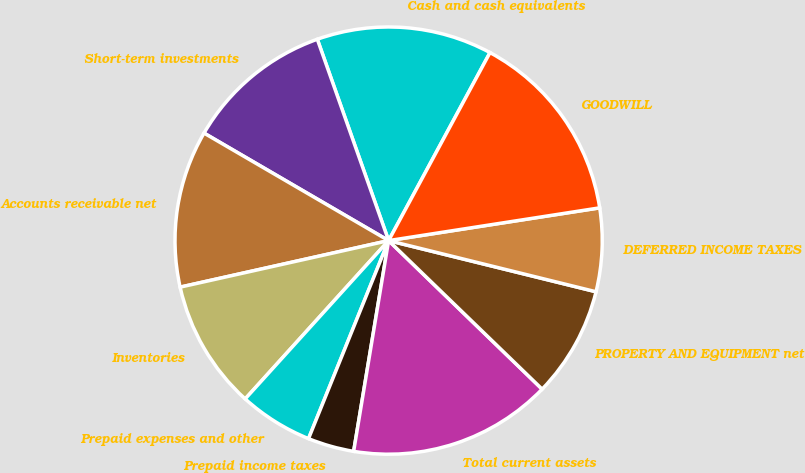Convert chart. <chart><loc_0><loc_0><loc_500><loc_500><pie_chart><fcel>Cash and cash equivalents<fcel>Short-term investments<fcel>Accounts receivable net<fcel>Inventories<fcel>Prepaid expenses and other<fcel>Prepaid income taxes<fcel>Total current assets<fcel>PROPERTY AND EQUIPMENT net<fcel>DEFERRED INCOME TAXES<fcel>GOODWILL<nl><fcel>13.29%<fcel>11.19%<fcel>11.89%<fcel>9.79%<fcel>5.6%<fcel>3.5%<fcel>15.38%<fcel>8.39%<fcel>6.3%<fcel>14.68%<nl></chart> 